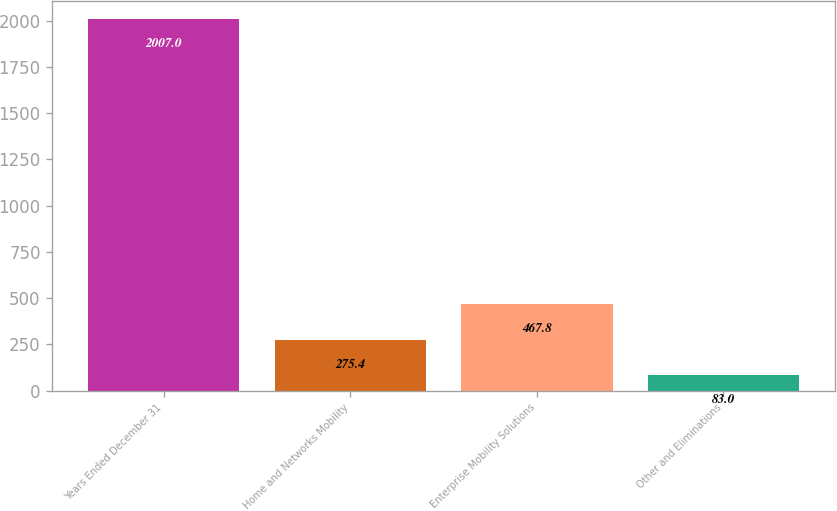<chart> <loc_0><loc_0><loc_500><loc_500><bar_chart><fcel>Years Ended December 31<fcel>Home and Networks Mobility<fcel>Enterprise Mobility Solutions<fcel>Other and Eliminations<nl><fcel>2007<fcel>275.4<fcel>467.8<fcel>83<nl></chart> 